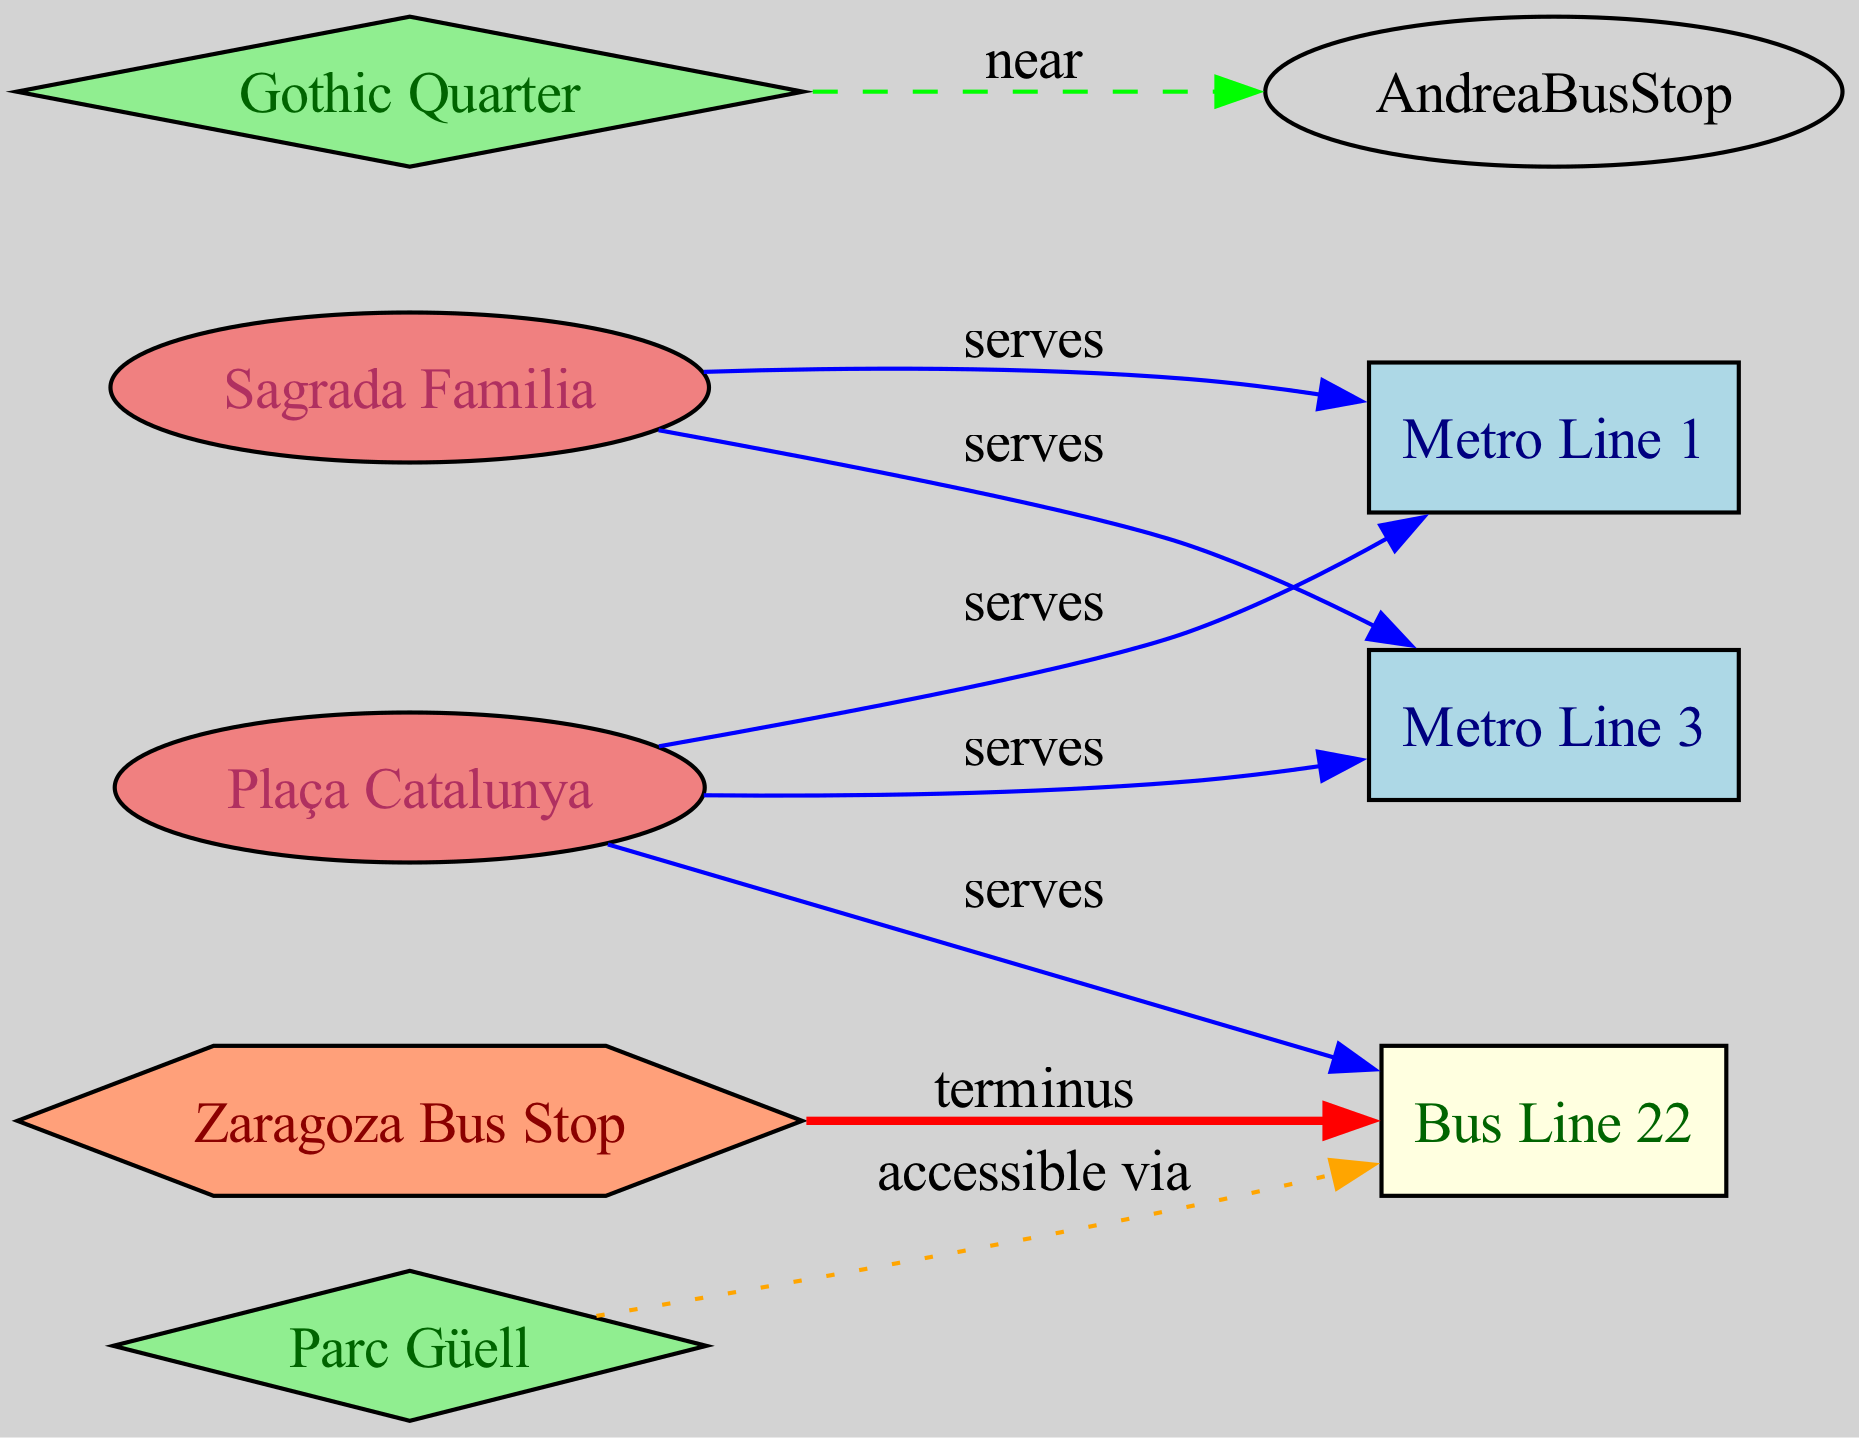What type of line serves Sagrada Familia? The diagram shows that both Metro Line 1 and Metro Line 3 serve the Sagrada Familia station. The specific edge labels indicate the connection between Sagrada Familia and these metro lines.
Answer: Metro Line 1, Metro Line 3 How many bus stops are shown on the diagram? The diagram only displays one bus stop, which is labeled as Zaragoza. This can be confirmed by counting the nodes of type "Bus Stop".
Answer: 1 Which line is a terminus at Zaragoza? The connection from Zaragoza to Bus Line 22 indicates that Zaragoza serves as a terminus for this bus line. The edge label confirms the relationship.
Answer: Bus Line 22 What is the relationship between Parc Güell and Bus Line 22? The diagram shows that Parc Güell is accessible via Bus Line 22, indicated by the edge labeled as “accessible via.” This suggests that Bus Line 22 provides a route to reach Parc Güell.
Answer: accessible via How many metro lines serve Plaça Catalunya? The diagram indicates that Plaça Catalunya is served by two metro lines: Metro Line 1 and Metro Line 3. This can be determined by examining the edges leading from Plaça Catalunya to these two lines.
Answer: 2 What is the connection type between Gothic Quarter and Andrea Bus Stop? The connection type shown in the diagram is labeled as "near". This indicates a proximity relationship, suggesting that the Gothic Quarter is located close to Andrea Bus Stop without a direct transport connection.
Answer: near Which bus line connects to Parc Güell? According to the edges in the diagram, Parc Güell is connected to Bus Line 22, as noted by the labeled edge "accessible via" from Parc Güell to the bus line.
Answer: Bus Line 22 Which metro line has the most connections in the diagram? By examining the edges, both Metro Line 1 and Metro Line 3 have similar numbers of connections, each associated with two different stations (Sagrada Familia and Plaça Catalunya). Thus, both have the highest number of connections.
Answer: Metro Line 1, Metro Line 3 What type of node is Plaça Catalunya? The diagram indicates that Plaça Catalunya is categorized as a “Metro Station / Landmark,” as shown by its node type designation in the diagram.
Answer: Metro Station / Landmark 